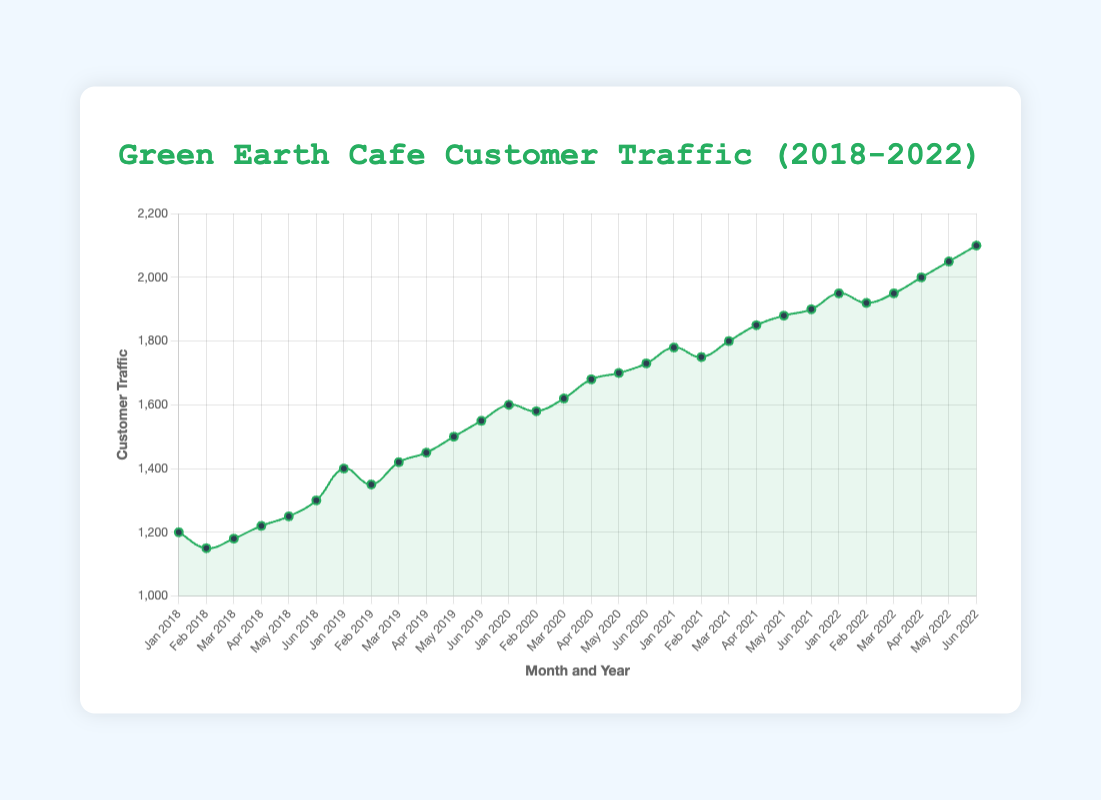What was the customer traffic in January 2020? Look at the data point plotted for January 2020 on the x-axis. The y-axis shows 1600.
Answer: 1600 How much did customer traffic increase from January 2018 to June 2022? The traffic in January 2018 was 1200 and in June 2022 was 2100. The increase is 2100 - 1200 = 900.
Answer: 900 When did the customer traffic first reach 2000? Search for the first data point that hits the 2000 mark on the y-axis. It is in April 2022.
Answer: April 2022 What is the average customer traffic in May of each year? Average = (Traffic in May 2018 + Traffic in May 2019 + Traffic in May 2020 + Traffic in May 2021 + Traffic in May 2022) / 5 = (1250 + 1500 + 1700 + 1880 + 2050) / 5 = 8380 / 5
Answer: 1676 Compare the customer traffic in February 2018 and February 2021. Which year had higher traffic? Customer traffic in February 2018 was 1150, and in February 2021 was 1750. February 2021 had higher traffic.
Answer: February 2021 What is the trend observed in customer traffic from January 2018 to June 2022? Generally, the traffic increases steadily over the years, with a rise from 1200 in January 2018 to 2100 in June 2022.
Answer: Increasing trend By how much did customer traffic grow from June 2019 to June 2020? Customer traffic in June 2019 was 1550 and in June 2020 it was 1730. The increase is 1730 - 1550 = 180.
Answer: 180 Which month and year showed the highest customer traffic? Scan the y-axis values for the highest point on the line chart. The highest traffic was 2100 in June 2022.
Answer: June 2022 Is there any month where customer traffic decreased compared to the previous month? If yes, name one. Look for points where the line goes down. Between January 2022 (1950) and February 2022 (1920), traffic decreased.
Answer: February 2022 What was the customer traffic in March 2019 compared to March 2020? Look at the data points for March in each year. March 2019 had 1420, and March 2020 had 1620.
Answer: March 2020 